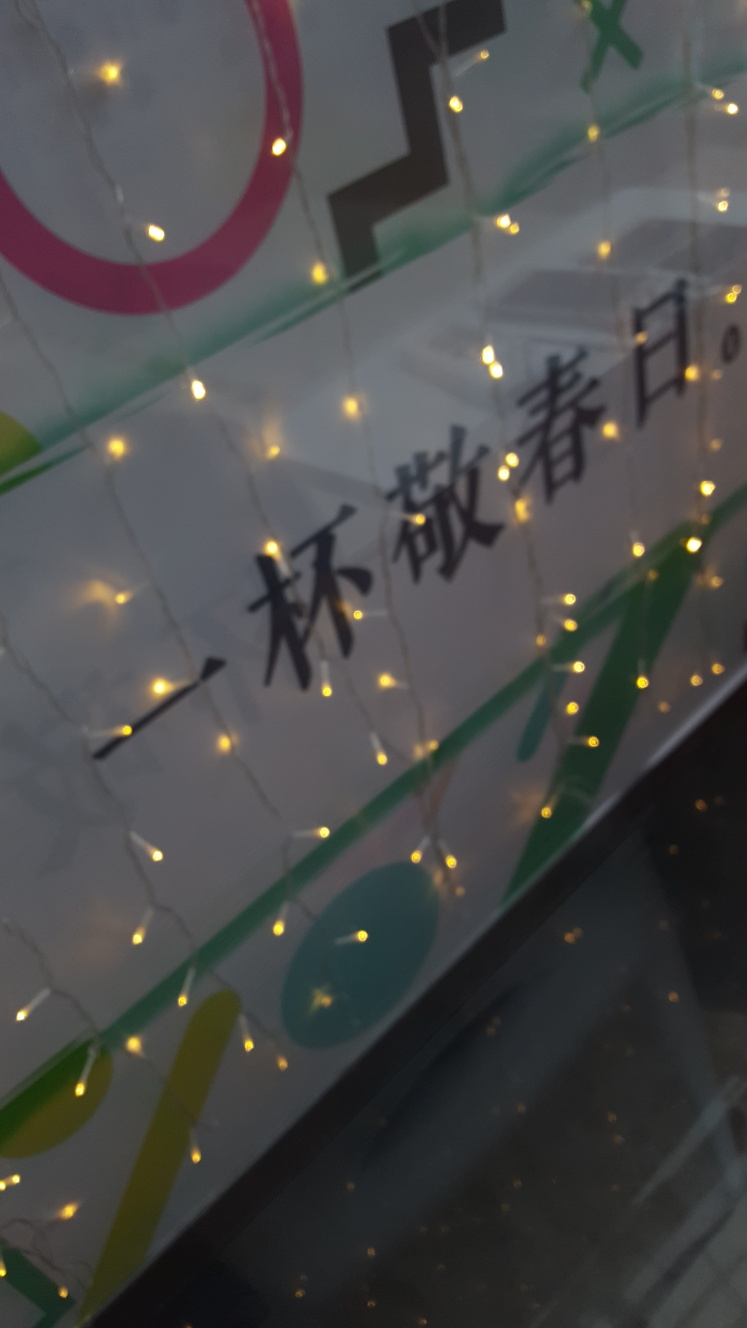Could these lights serve a functional purpose aside from decoration? Certainly, aside from their decorative appeal, such lights can provide soft and diffused illumination that improves visibility in the area. They can serve to highlight pathways, mark boundaries, or gently light up a space without the harshness of direct lighting, making them versatile both aesthetically and functionally. 